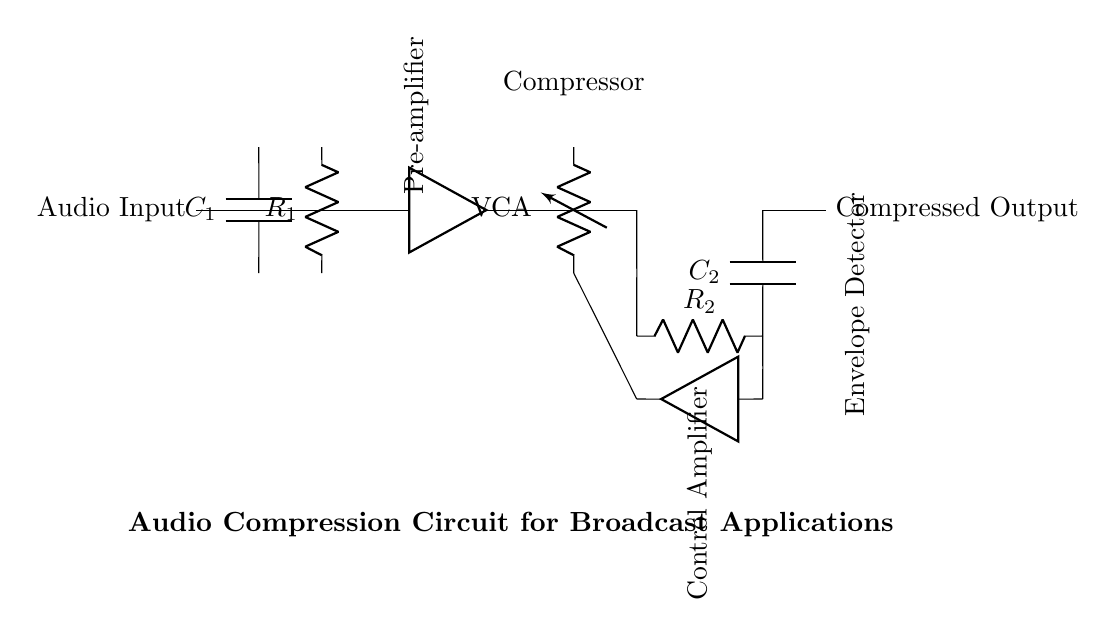What type of component is C1? C1 is a capacitor, as indicated by the symbol and label in the diagram.
Answer: Capacitor What is the function of the compressor in this circuit? The compressor reduces the dynamic range of the audio signal to optimize sound levels, allowing for a more uniform output.
Answer: Reduces dynamic range What is the value of resistor R1? The value of R1 is not specified in the diagram; it's denoted as R1, but no numerical value is provided.
Answer: Not specified How many amplifiers are present in the circuit? The diagram shows two amplifiers, one before the compressor and one in the control section.
Answer: Two What is the role of the envelope detector in this circuit? The envelope detector processes the audio signal to extract the envelope, which helps in controlling the compressor's gain.
Answer: Extracts envelope How does the control amplifier interact with the compressor? The control amplifier adjusts the control voltage applied to the compressor based on the output of the envelope detector, affecting the gain reduction.
Answer: Adjusts gain What is the output of the circuit labeled as? The output of the circuit is labeled as "Compressed Output," indicating the sound has been processed.
Answer: Compressed Output 